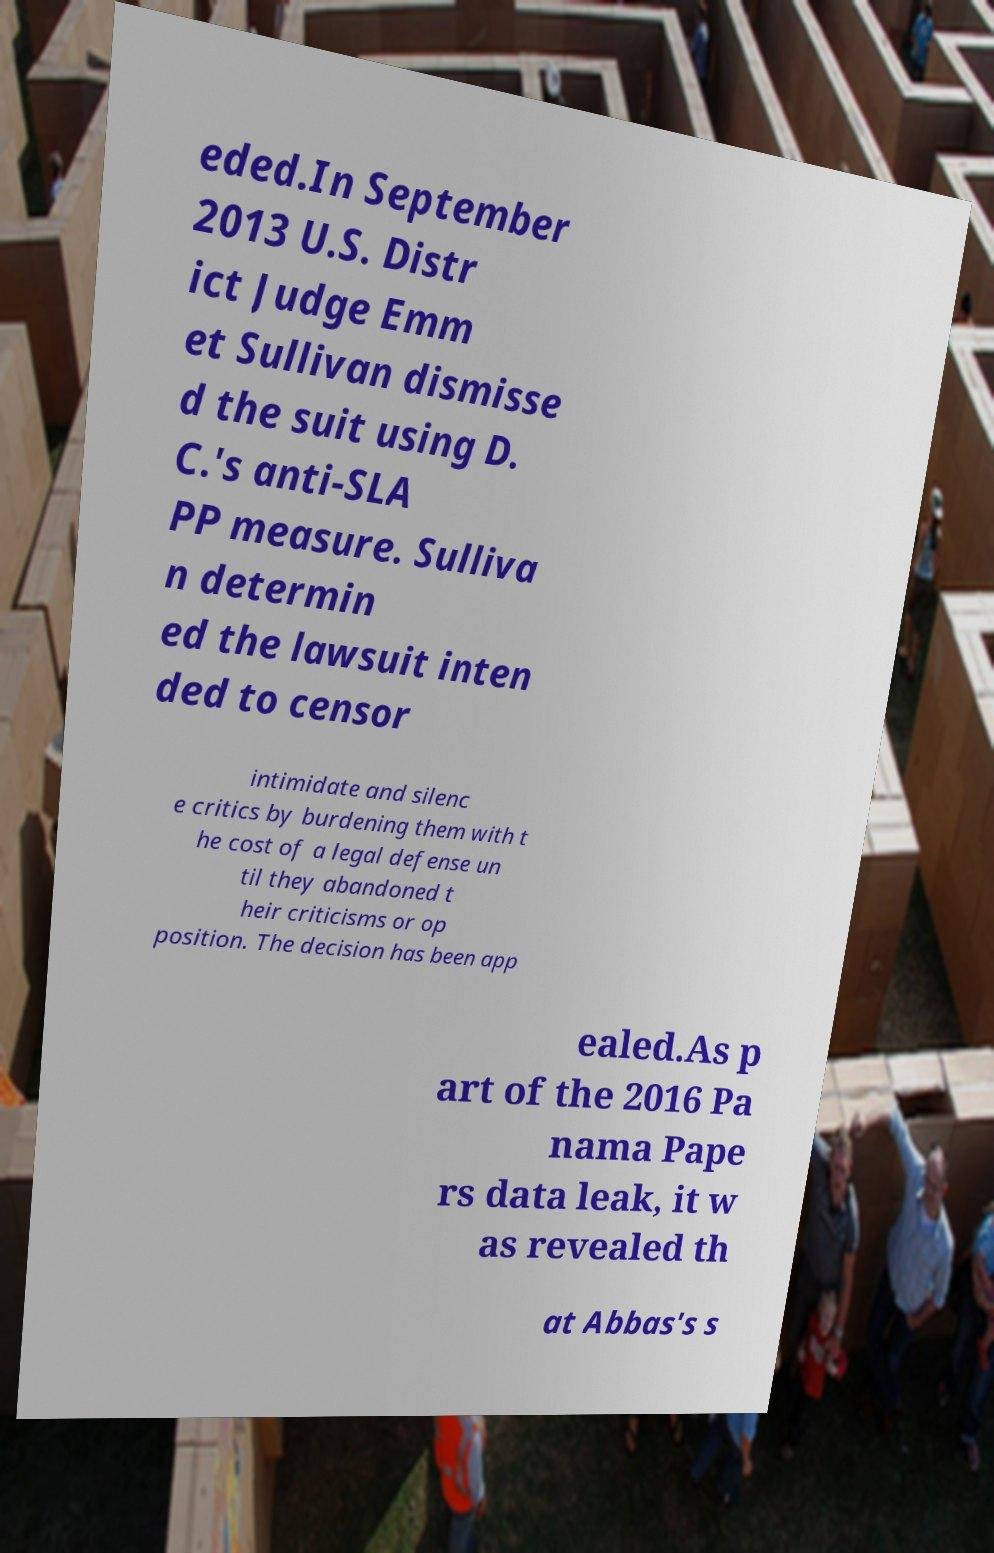What messages or text are displayed in this image? I need them in a readable, typed format. eded.In September 2013 U.S. Distr ict Judge Emm et Sullivan dismisse d the suit using D. C.'s anti-SLA PP measure. Sulliva n determin ed the lawsuit inten ded to censor intimidate and silenc e critics by burdening them with t he cost of a legal defense un til they abandoned t heir criticisms or op position. The decision has been app ealed.As p art of the 2016 Pa nama Pape rs data leak, it w as revealed th at Abbas's s 